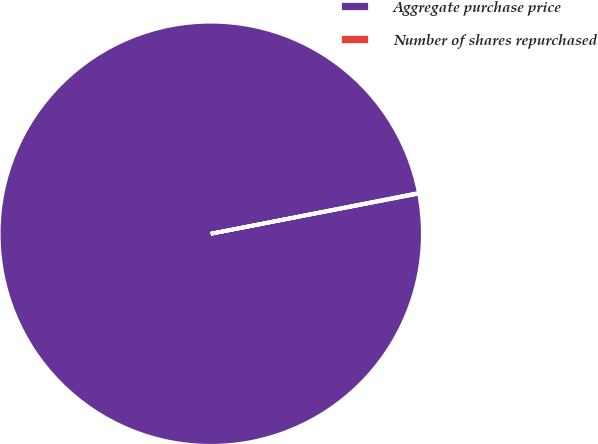Convert chart. <chart><loc_0><loc_0><loc_500><loc_500><pie_chart><fcel>Aggregate purchase price<fcel>Number of shares repurchased<nl><fcel>99.96%<fcel>0.04%<nl></chart> 